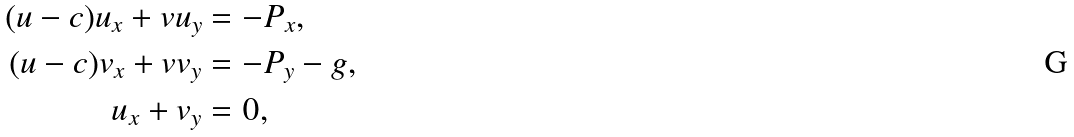Convert formula to latex. <formula><loc_0><loc_0><loc_500><loc_500>( u - c ) u _ { x } + v u _ { y } & = - P _ { x } , \\ ( u - c ) v _ { x } + v v _ { y } & = - P _ { y } - g , \\ u _ { x } + v _ { y } & = 0 ,</formula> 